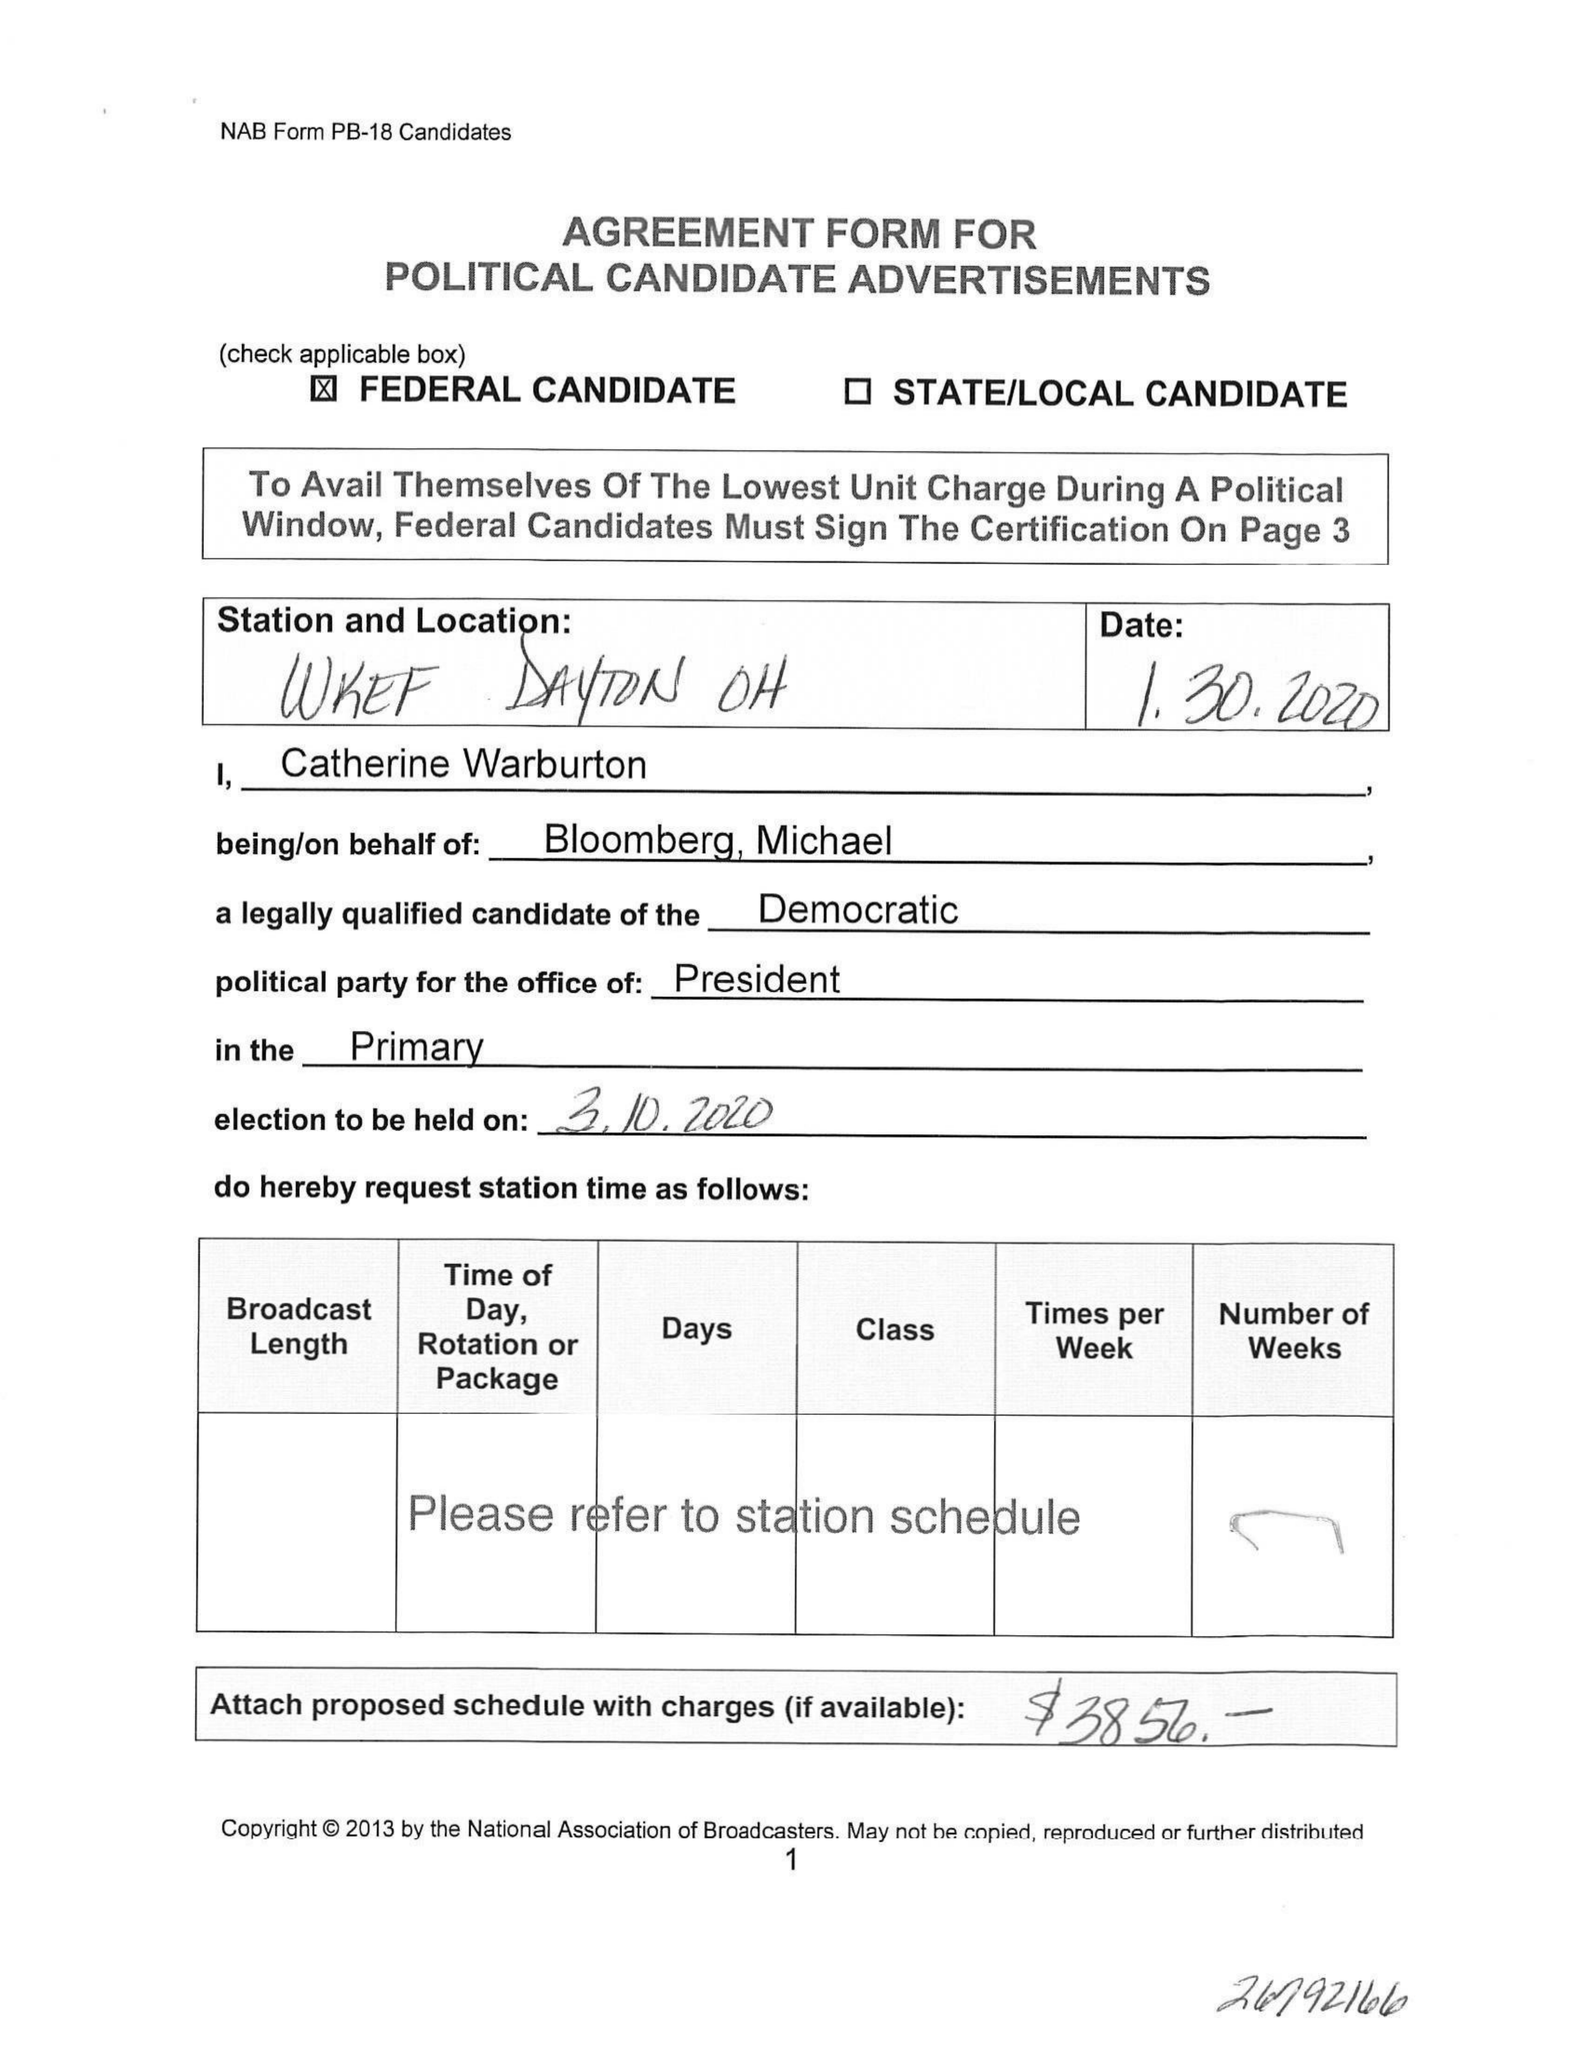What is the value for the advertiser?
Answer the question using a single word or phrase. None 